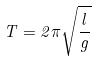<formula> <loc_0><loc_0><loc_500><loc_500>T = 2 \pi \sqrt { \frac { l } { g } }</formula> 